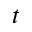<formula> <loc_0><loc_0><loc_500><loc_500>t</formula> 